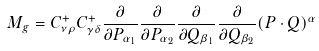Convert formula to latex. <formula><loc_0><loc_0><loc_500><loc_500>M _ { g } = C ^ { + } _ { \nu \rho } C ^ { + } _ { \gamma \delta } \frac { \partial } { \partial P _ { \alpha _ { 1 } } } \frac { \partial } { \partial P _ { \alpha _ { 2 } } } \frac { \partial } { \partial Q _ { \beta _ { 1 } } } \frac { \partial } { \partial Q _ { \beta _ { 2 } } } ( P \cdot Q ) ^ { \alpha }</formula> 